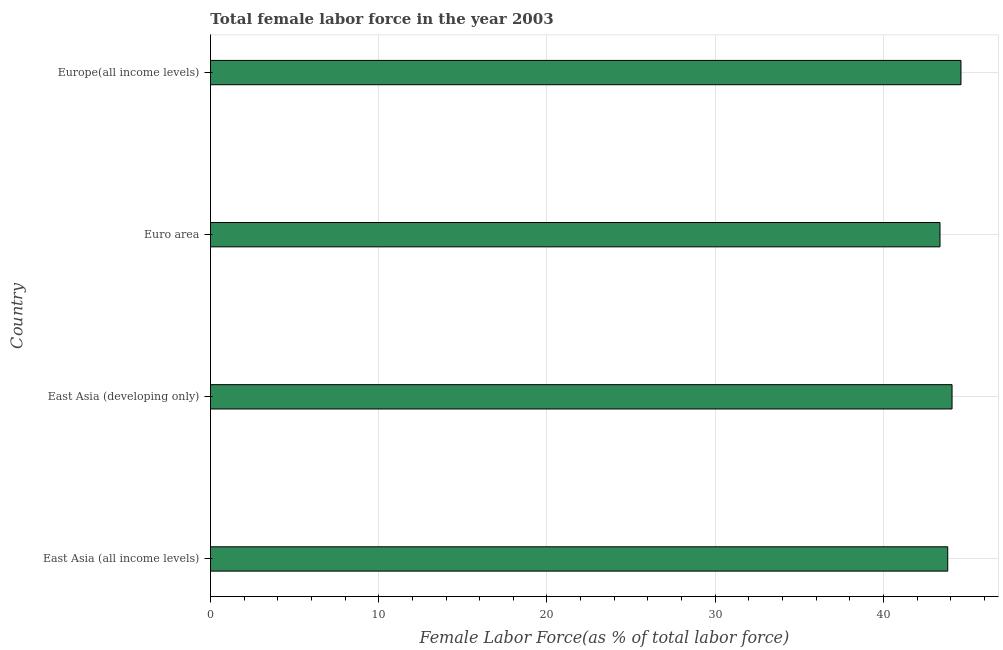Does the graph contain grids?
Give a very brief answer. Yes. What is the title of the graph?
Ensure brevity in your answer.  Total female labor force in the year 2003. What is the label or title of the X-axis?
Keep it short and to the point. Female Labor Force(as % of total labor force). What is the label or title of the Y-axis?
Make the answer very short. Country. What is the total female labor force in East Asia (all income levels)?
Your answer should be very brief. 43.82. Across all countries, what is the maximum total female labor force?
Provide a succinct answer. 44.61. Across all countries, what is the minimum total female labor force?
Give a very brief answer. 43.36. In which country was the total female labor force maximum?
Offer a very short reply. Europe(all income levels). In which country was the total female labor force minimum?
Make the answer very short. Euro area. What is the sum of the total female labor force?
Give a very brief answer. 175.87. What is the difference between the total female labor force in East Asia (all income levels) and Europe(all income levels)?
Offer a terse response. -0.79. What is the average total female labor force per country?
Provide a short and direct response. 43.97. What is the median total female labor force?
Offer a very short reply. 43.95. In how many countries, is the total female labor force greater than 10 %?
Provide a short and direct response. 4. Is the total female labor force in East Asia (developing only) less than that in Euro area?
Your response must be concise. No. Is the difference between the total female labor force in East Asia (all income levels) and East Asia (developing only) greater than the difference between any two countries?
Provide a short and direct response. No. What is the difference between the highest and the second highest total female labor force?
Keep it short and to the point. 0.53. What is the Female Labor Force(as % of total labor force) in East Asia (all income levels)?
Make the answer very short. 43.82. What is the Female Labor Force(as % of total labor force) of East Asia (developing only)?
Your response must be concise. 44.08. What is the Female Labor Force(as % of total labor force) of Euro area?
Keep it short and to the point. 43.36. What is the Female Labor Force(as % of total labor force) of Europe(all income levels)?
Your answer should be compact. 44.61. What is the difference between the Female Labor Force(as % of total labor force) in East Asia (all income levels) and East Asia (developing only)?
Your response must be concise. -0.26. What is the difference between the Female Labor Force(as % of total labor force) in East Asia (all income levels) and Euro area?
Keep it short and to the point. 0.46. What is the difference between the Female Labor Force(as % of total labor force) in East Asia (all income levels) and Europe(all income levels)?
Provide a succinct answer. -0.79. What is the difference between the Female Labor Force(as % of total labor force) in East Asia (developing only) and Euro area?
Your answer should be very brief. 0.72. What is the difference between the Female Labor Force(as % of total labor force) in East Asia (developing only) and Europe(all income levels)?
Ensure brevity in your answer.  -0.53. What is the difference between the Female Labor Force(as % of total labor force) in Euro area and Europe(all income levels)?
Keep it short and to the point. -1.25. What is the ratio of the Female Labor Force(as % of total labor force) in East Asia (all income levels) to that in East Asia (developing only)?
Your response must be concise. 0.99. What is the ratio of the Female Labor Force(as % of total labor force) in East Asia (all income levels) to that in Euro area?
Keep it short and to the point. 1.01. What is the ratio of the Female Labor Force(as % of total labor force) in East Asia (all income levels) to that in Europe(all income levels)?
Your answer should be compact. 0.98. What is the ratio of the Female Labor Force(as % of total labor force) in East Asia (developing only) to that in Euro area?
Keep it short and to the point. 1.02. 